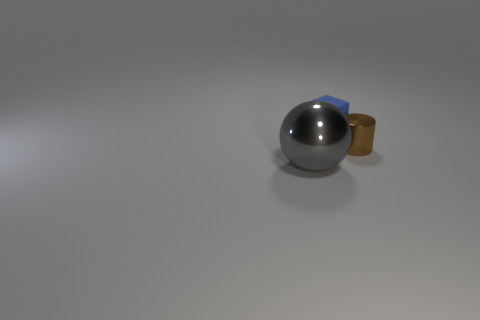Add 3 cylinders. How many objects exist? 6 Subtract all cubes. How many objects are left? 2 Subtract 0 brown blocks. How many objects are left? 3 Subtract all yellow cylinders. Subtract all brown balls. How many cylinders are left? 1 Subtract all blue blocks. Subtract all small cubes. How many objects are left? 1 Add 1 tiny rubber things. How many tiny rubber things are left? 2 Add 2 red rubber spheres. How many red rubber spheres exist? 2 